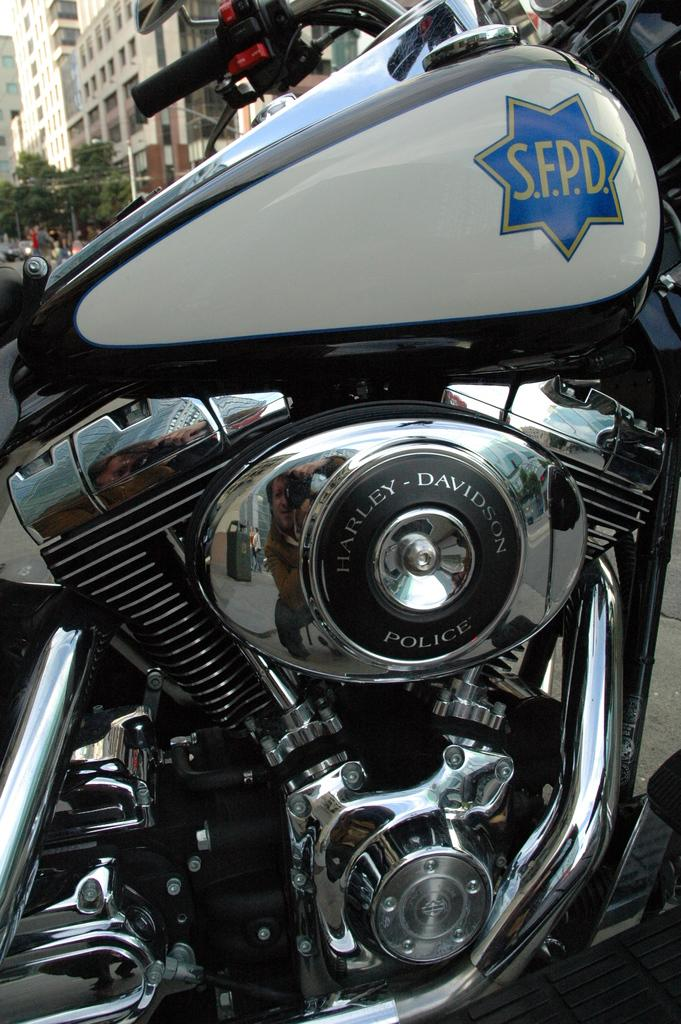What is the main object in the image? There is a bike in the image. What materials were used to make the bike? The bike is made of steel and iron. What can be seen in the background of the image? There are buildings and trees in the background of the image. What type of thread is being used to hold the bike together in the image? There is no thread visible in the image, and the bike is made of steel and iron, not thread. 